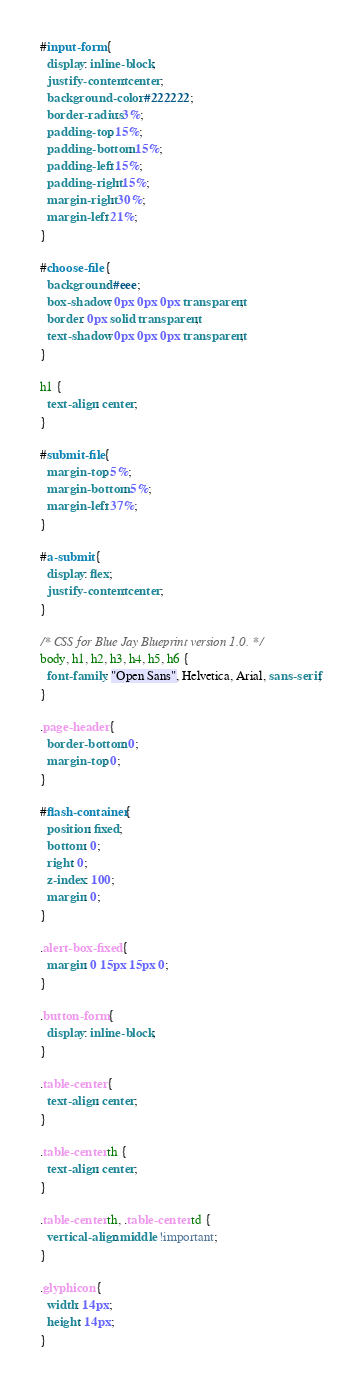<code> <loc_0><loc_0><loc_500><loc_500><_CSS_>#input-form {
  display: inline-block;
  justify-content: center;
  background-color: #222222;
  border-radius: 3%;
  padding-top: 15%;
  padding-bottom: 15%;
  padding-left: 15%;
  padding-right: 15%;
  margin-right: 30%;
  margin-left: 21%;
}

#choose-file {
  background: #eee;
  box-shadow: 0px 0px 0px transparent;
  border: 0px solid transparent;
  text-shadow: 0px 0px 0px transparent;
}

h1 {
  text-align: center;
}

#submit-file {
  margin-top: 5%;
  margin-bottom: 5%;
  margin-left: 37%;
}

#a-submit {
  display: flex;
  justify-content: center;
}

/* CSS for Blue Jay Blueprint version 1.0. */
body, h1, h2, h3, h4, h5, h6 {
  font-family: "Open Sans", Helvetica, Arial, sans-serif;
}

.page-header {
  border-bottom: 0;
  margin-top: 0;
}

#flash-container {
  position: fixed;
  bottom: 0;
  right: 0;
  z-index: 100;
  margin: 0;
}

.alert-box-fixed {
  margin: 0 15px 15px 0;
}

.button-form {
  display: inline-block;
}

.table-center {
  text-align: center;
}

.table-center th {
  text-align: center;
}

.table-center th, .table-center td {
  vertical-align: middle !important;
}

.glyphicon {
  width: 14px;
  height: 14px;
}
</code> 